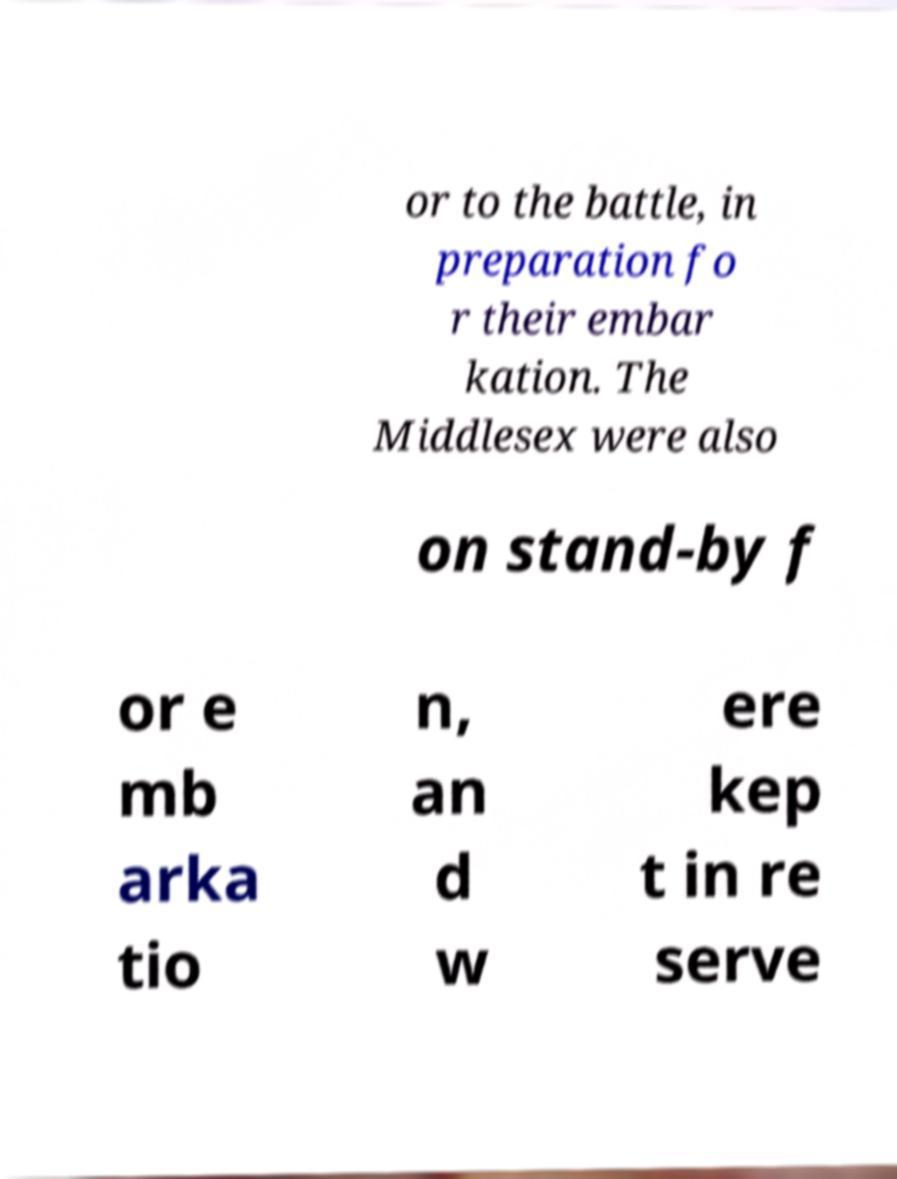I need the written content from this picture converted into text. Can you do that? or to the battle, in preparation fo r their embar kation. The Middlesex were also on stand-by f or e mb arka tio n, an d w ere kep t in re serve 